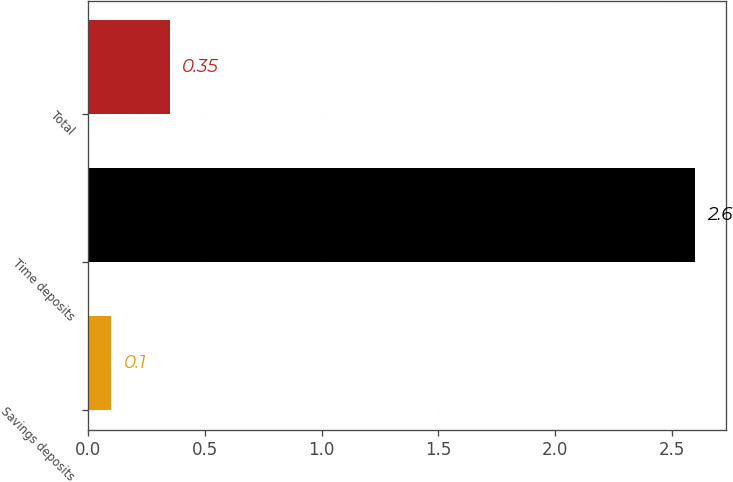Convert chart. <chart><loc_0><loc_0><loc_500><loc_500><bar_chart><fcel>Savings deposits<fcel>Time deposits<fcel>Total<nl><fcel>0.1<fcel>2.6<fcel>0.35<nl></chart> 